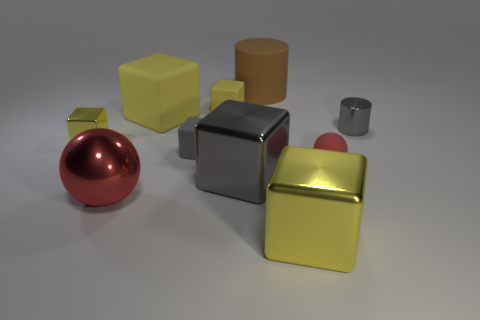Subtract all yellow cubes. How many were subtracted if there are1yellow cubes left? 3 Subtract all tiny yellow blocks. How many blocks are left? 4 Subtract all gray blocks. How many blocks are left? 4 Subtract all blocks. How many objects are left? 4 Subtract 5 cubes. How many cubes are left? 1 Add 2 red rubber balls. How many red rubber balls are left? 3 Add 6 tiny cylinders. How many tiny cylinders exist? 7 Subtract 1 gray blocks. How many objects are left? 9 Subtract all green balls. Subtract all yellow cylinders. How many balls are left? 2 Subtract all blue balls. How many gray cubes are left? 2 